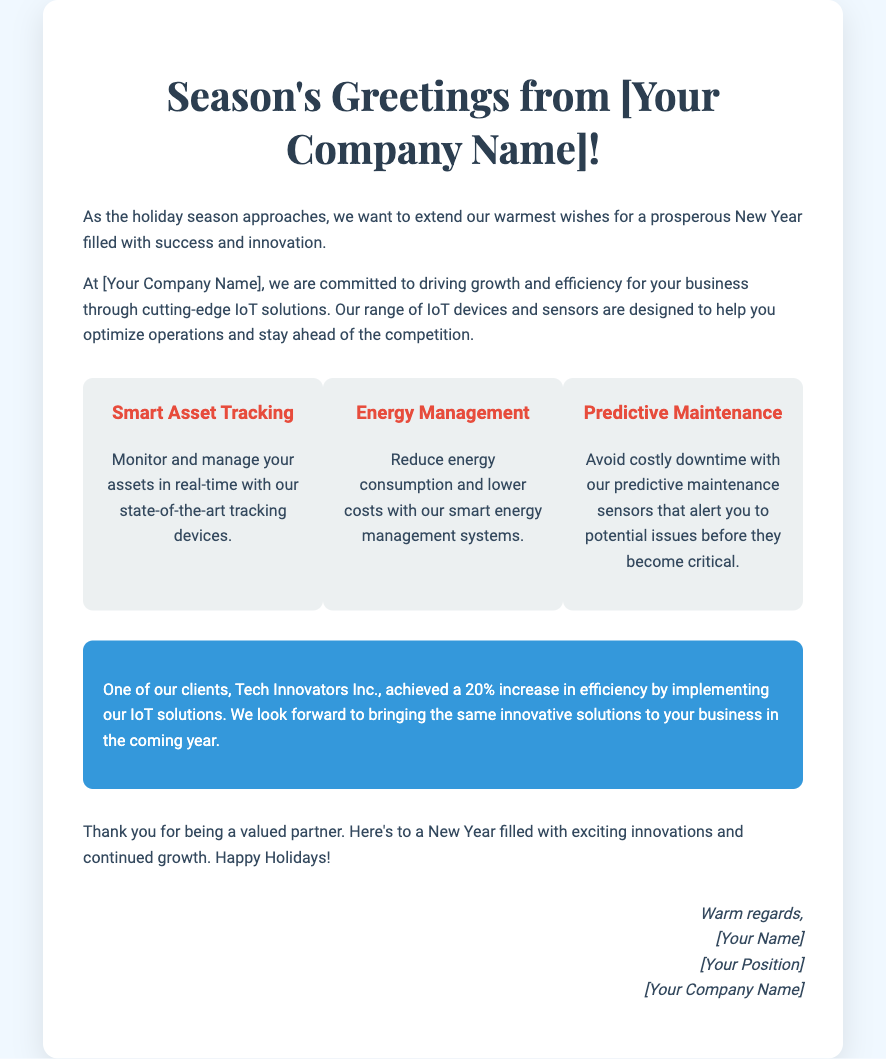What is the name of the company sending the greetings? The company sending the greetings is identified as [Your Company Name] in the card.
Answer: [Your Company Name] What is one of the solutions mentioned for asset management? The card mentions "Smart Asset Tracking" as one of the solutions for asset management.
Answer: Smart Asset Tracking What percentage of efficiency increase did Tech Innovators Inc. achieve? The document states that Tech Innovators Inc. achieved a 20% increase in efficiency after implementing the IoT solutions.
Answer: 20% What holiday wishes are extended in the greeting card? The card wishes for a prosperous New Year filled with success and innovation.
Answer: A prosperous New Year filled with success and innovation What style of font is used for the header? The header of the card uses the 'Playfair Display' font family.
Answer: Playfair Display How many IoT solutions are highlighted in the greetings? The document highlights three specific IoT solutions.
Answer: Three Who signed off the holiday card? The signature section mentions [Your Name] as the person signing off the card.
Answer: [Your Name] What visual elements are used in the card's design? The card features holiday-themed elements and a festive design to complement the greetings.
Answer: Holiday-themed elements 